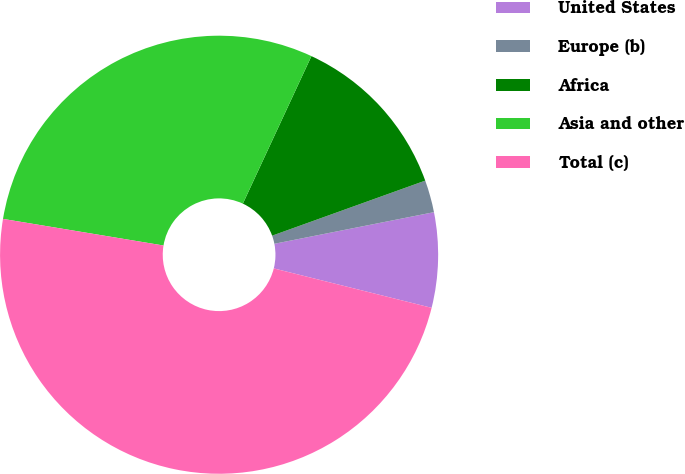<chart> <loc_0><loc_0><loc_500><loc_500><pie_chart><fcel>United States<fcel>Europe (b)<fcel>Africa<fcel>Asia and other<fcel>Total (c)<nl><fcel>7.01%<fcel>2.38%<fcel>12.58%<fcel>29.31%<fcel>48.72%<nl></chart> 